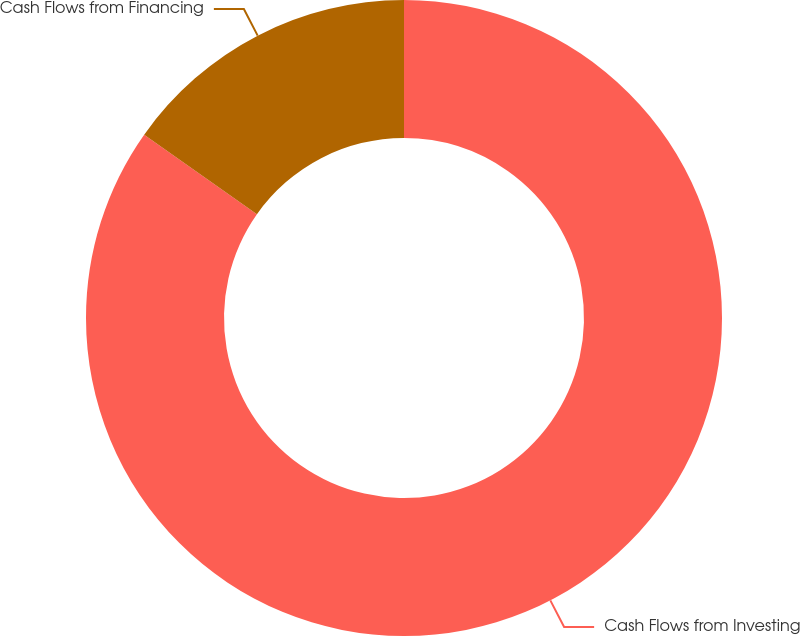<chart> <loc_0><loc_0><loc_500><loc_500><pie_chart><fcel>Cash Flows from Investing<fcel>Cash Flows from Financing<nl><fcel>84.78%<fcel>15.22%<nl></chart> 